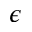Convert formula to latex. <formula><loc_0><loc_0><loc_500><loc_500>\epsilon</formula> 